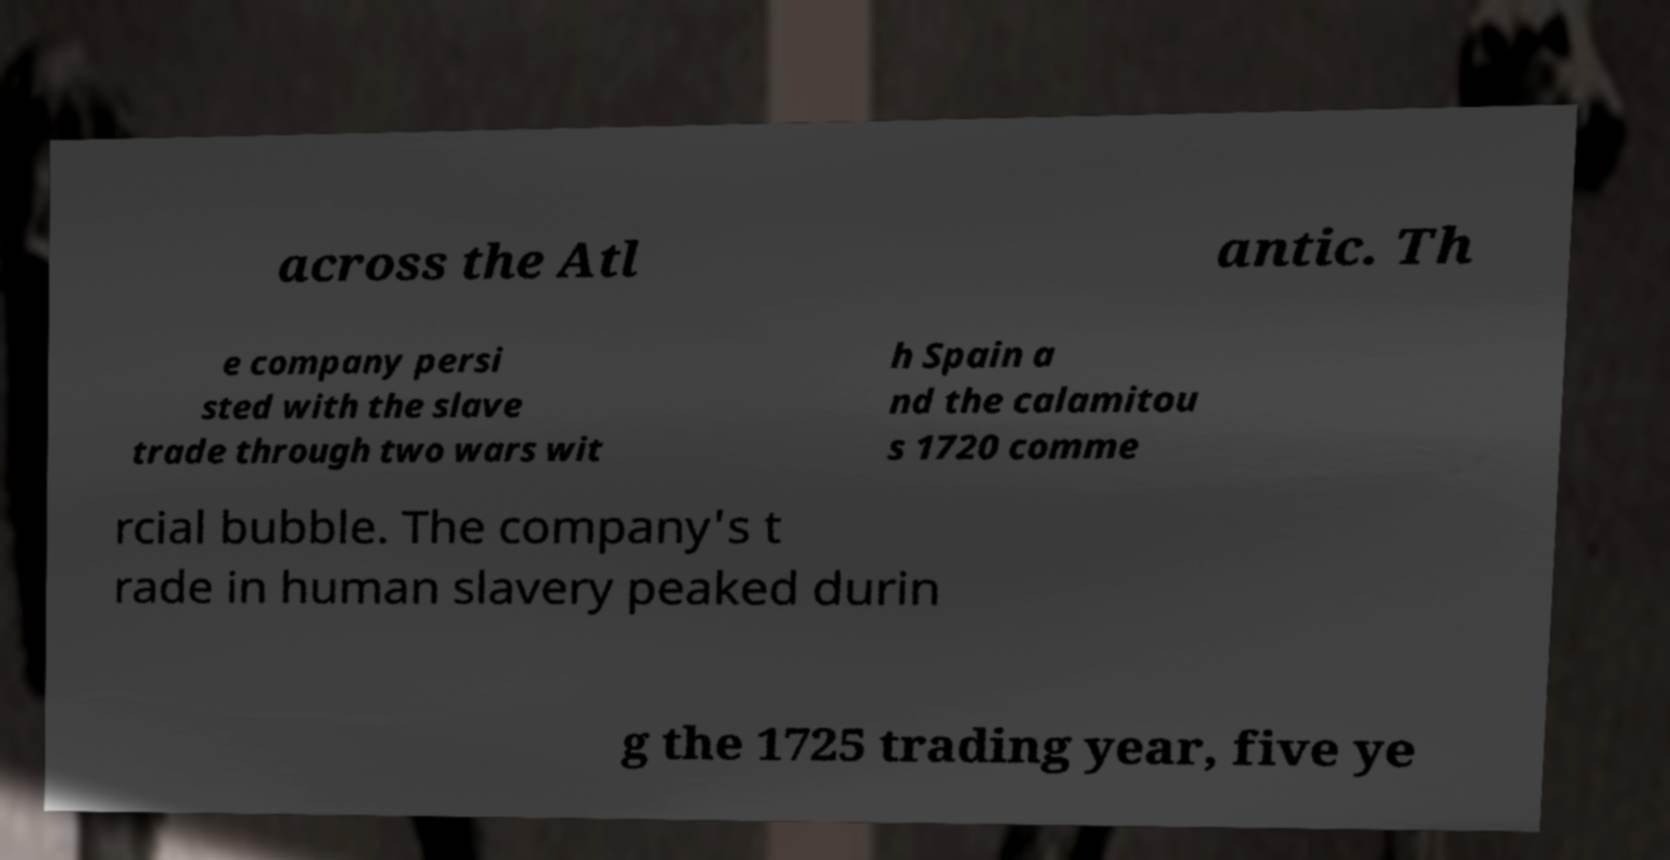Can you read and provide the text displayed in the image?This photo seems to have some interesting text. Can you extract and type it out for me? across the Atl antic. Th e company persi sted with the slave trade through two wars wit h Spain a nd the calamitou s 1720 comme rcial bubble. The company's t rade in human slavery peaked durin g the 1725 trading year, five ye 